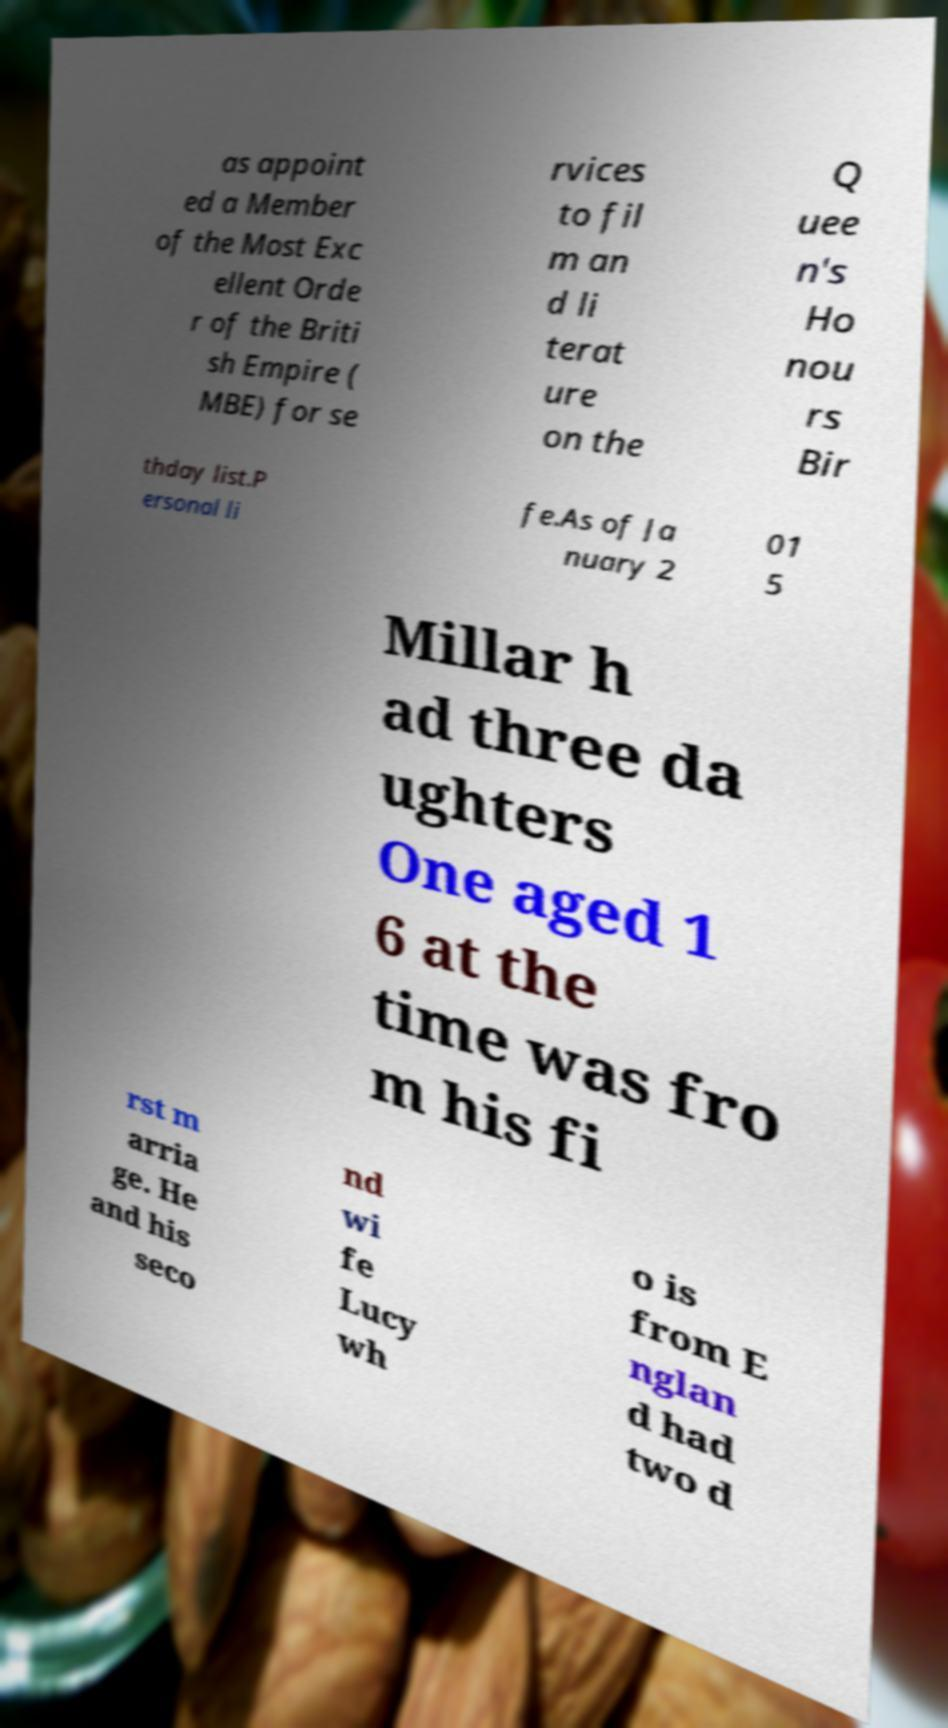Could you assist in decoding the text presented in this image and type it out clearly? as appoint ed a Member of the Most Exc ellent Orde r of the Briti sh Empire ( MBE) for se rvices to fil m an d li terat ure on the Q uee n's Ho nou rs Bir thday list.P ersonal li fe.As of Ja nuary 2 01 5 Millar h ad three da ughters One aged 1 6 at the time was fro m his fi rst m arria ge. He and his seco nd wi fe Lucy wh o is from E nglan d had two d 